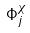<formula> <loc_0><loc_0><loc_500><loc_500>\Phi _ { j } ^ { \chi }</formula> 